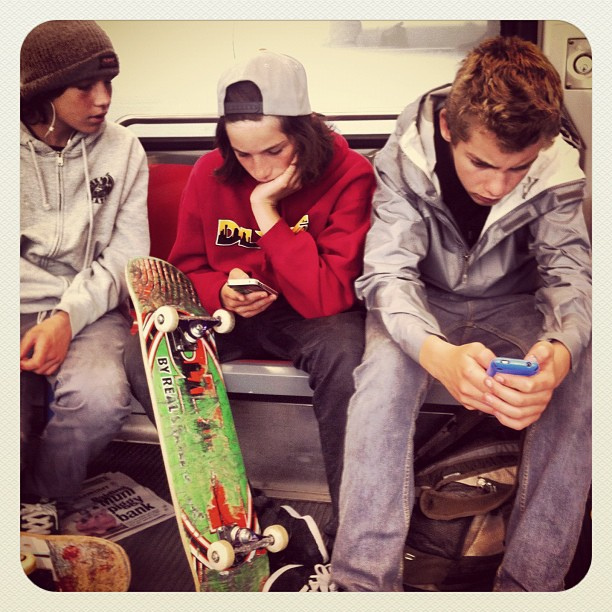Identify and read out the text in this image. BY REAL piggy bank 